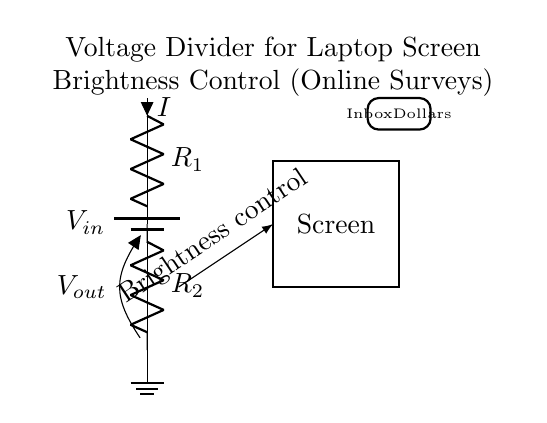What components are present in the circuit? The circuit contains a battery, two resistors, and a screen. The battery provides the voltage, the resistors form the voltage divider, and the screen receives the adjusted voltage.
Answer: battery, two resistors, screen What does Vout represent in this circuit? Vout is the output voltage across the second resistor, R2. It represents the voltage that determines the brightness of the laptop screen by adjusting the proportion of voltage from the battery that is dropped across R2.
Answer: output voltage What is the purpose of the voltage divider in this circuit? The voltage divider adjusts the voltage supplied to the screen, allowing for control of the brightness. By changing the resistance values of R1 and R2, the output voltage Vout can be varied, providing a method to dim or brighten the screen as needed.
Answer: adjust brightness How does the current flow in this circuit? Current flows from the battery through R1 and R2, ultimately reaching the laptop screen. The series arrangement of the resistors dictates that the same current flows through R1 and R2, which directly influences the voltage drop across R2 and hence Vout.
Answer: series current What would happen if R2 is increased? Increasing R2 would result in a higher output voltage, which means the screen would become brighter. This is because a larger resistance allows more voltage to drop across it compared to R1 in the voltage divider configuration.
Answer: screen brightness increases What is the role of the ground in this circuit? The ground serves as a reference point for the circuit, providing a return path for the current. It ensures that the circuit is balanced and can help establish the potential difference necessary for voltage division to occur effectively.
Answer: reference point 